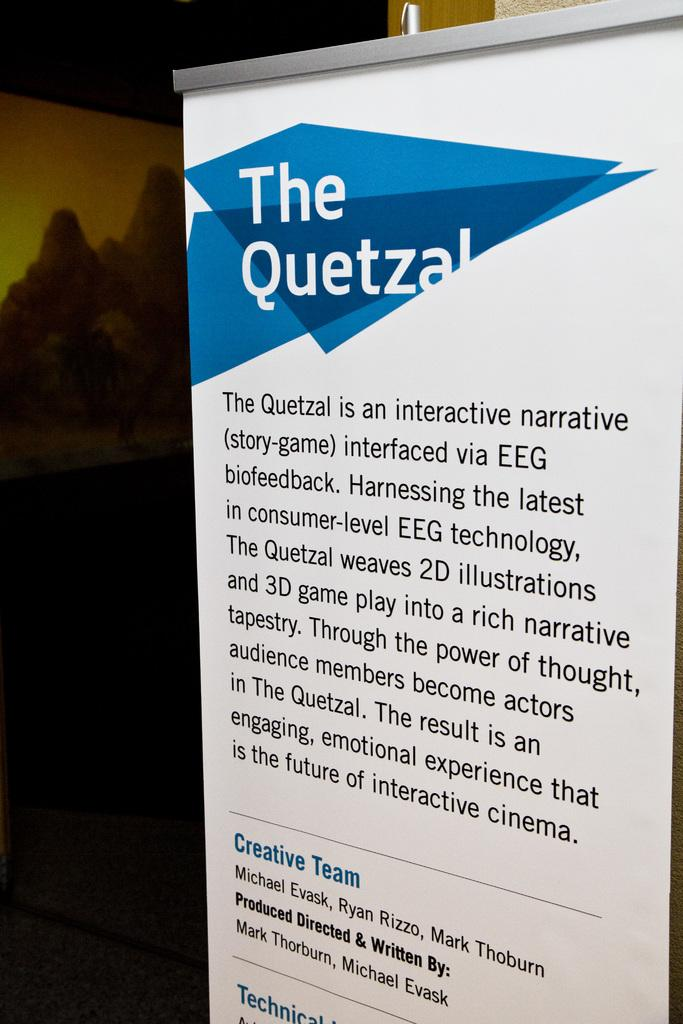<image>
Offer a succinct explanation of the picture presented. A banner describing an interactive narrative game called The Quetzal 